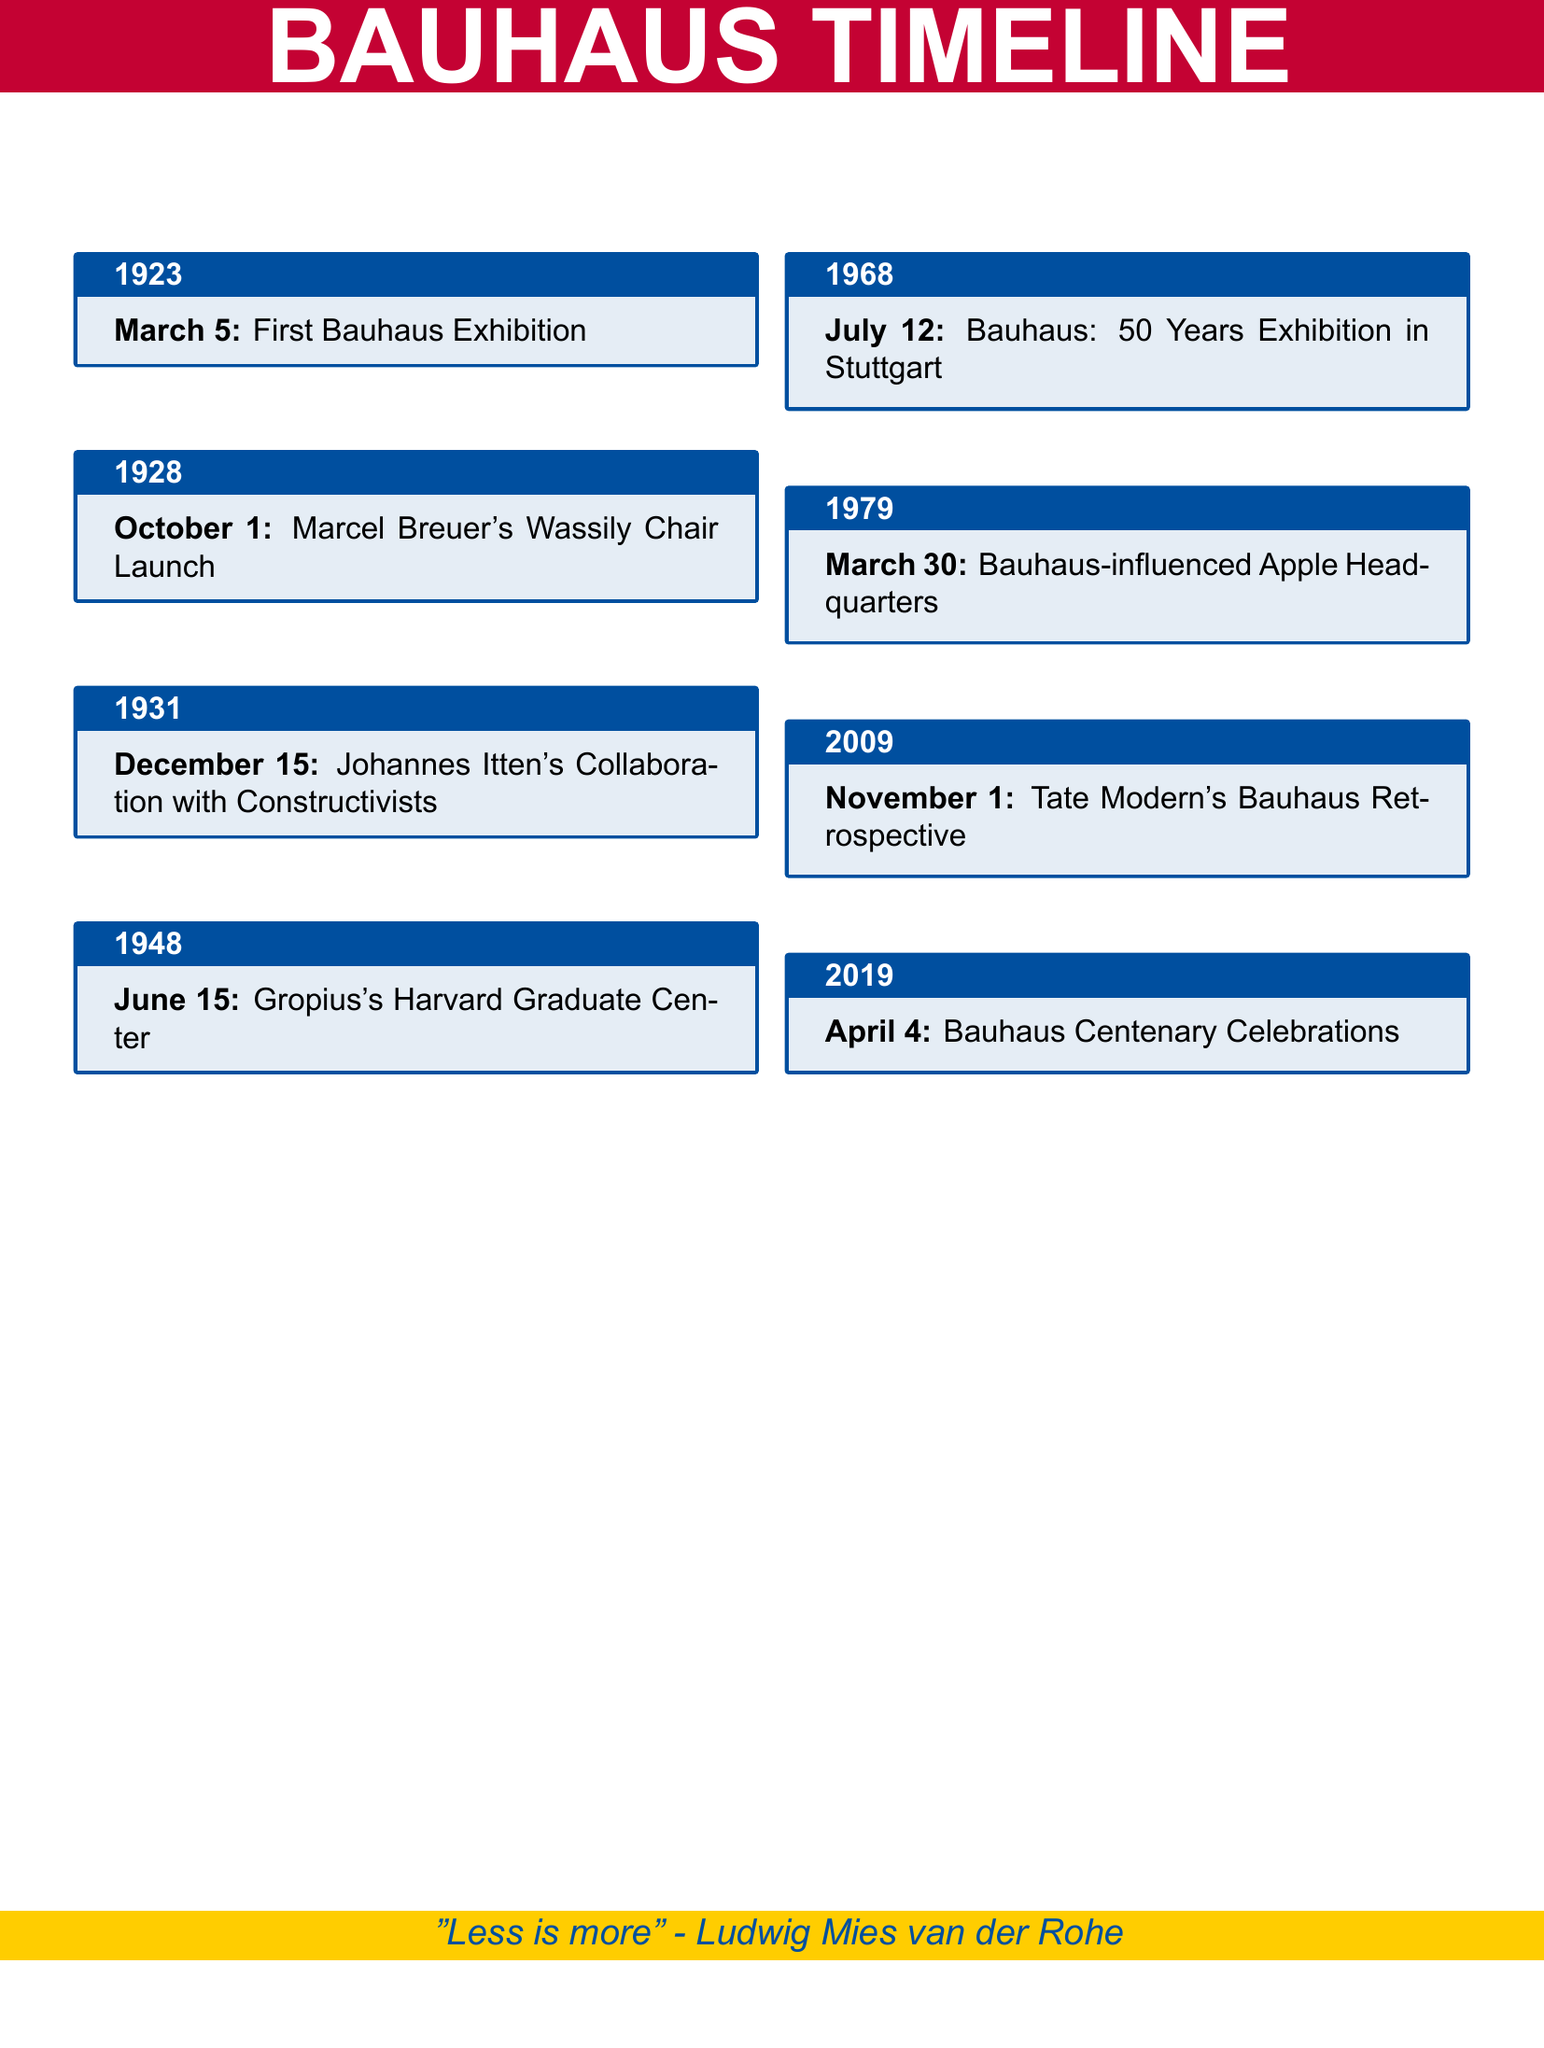What was the first Bauhaus Exhibition date? The document lists "March 5" as the date of the first Bauhaus Exhibition.
Answer: March 5 Which chair was launched on October 1, 1928? The document mentions Marcel Breuer's Wassily Chair as being launched on that date.
Answer: Wassily Chair What significant collaboration happened on December 15, 1931? The document states that Johannes Itten collaborated with Constructivists on that date.
Answer: Collaboration with Constructivists When was Gropius's Harvard Graduate Center completed? The document indicates that this event took place on June 15, 1948.
Answer: June 15 Which exhibition showcased Bauhaus influence in 1979? The document refers to the "Bauhaus: 50 Years Exhibition in Stuttgart" occurring on July 12, 1979.
Answer: Bauhaus: 50 Years Exhibition in Stuttgart What Bauhaus-influenced project opened on March 30, 2009? The text denotes the "Bauhaus-influenced Apple Headquarters" as the project opened on that date.
Answer: Bauhaus-influenced Apple Headquarters What retrospective did Tate Modern hold on November 1, 2019? According to the document, Tate Modern's "Bauhaus Retrospective" took place on that date.
Answer: Bauhaus Retrospective What notable celebration occurred on April 4, 2019? The document states that the "Bauhaus Centenary Celebrations" were held on this date.
Answer: Bauhaus Centenary Celebrations Which quote is featured in the document? The document includes the quote "Less is more" by Ludwig Mies van der Rohe.
Answer: "Less is more" - Ludwig Mies van der Rohe 